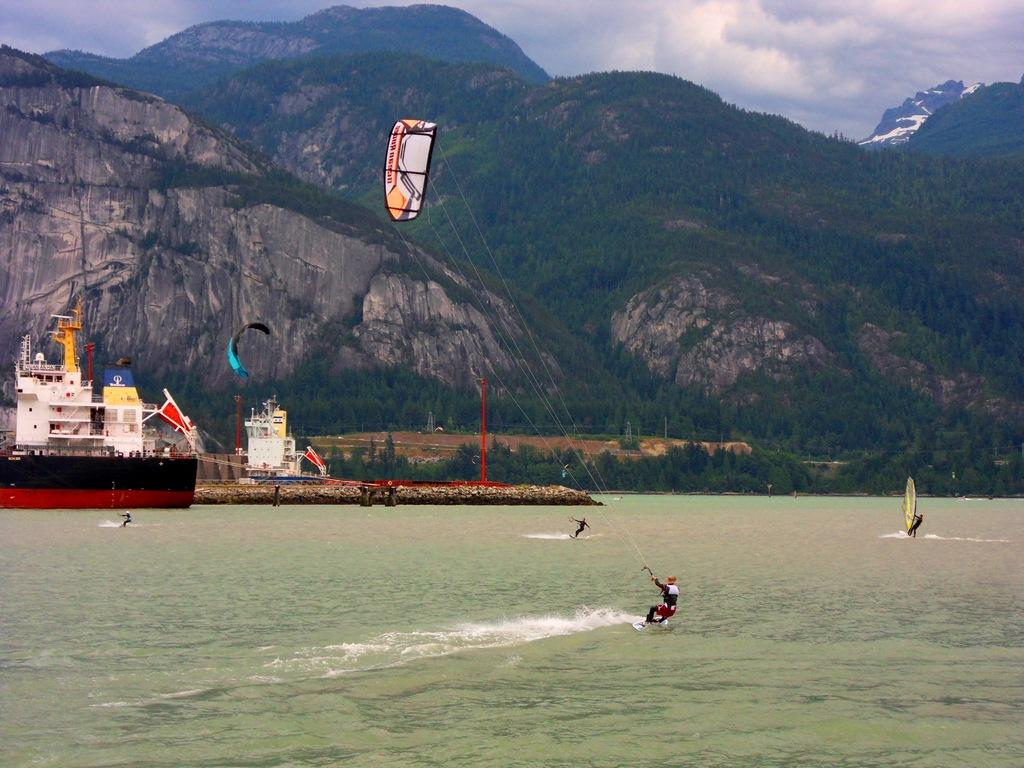What is the main subject of the picture? The main subject of the picture is a ship. What activity is taking place near the ship? There are people kite surfing on the water near the ship. Are there any people on the ship? Yes, there is a human on the boat. What type of landscape can be seen in the picture? There are trees and hills visible in the picture. How would you describe the sky in the image? The sky is blue and cloudy. What type of cub is playing with a stocking in the image? There is no cub or stocking present in the image. How does the ship show respect to the kite surfers in the image? The ship does not show respect to the kite surfers in the image, as it is an inanimate object and cannot display emotions or intentions. 